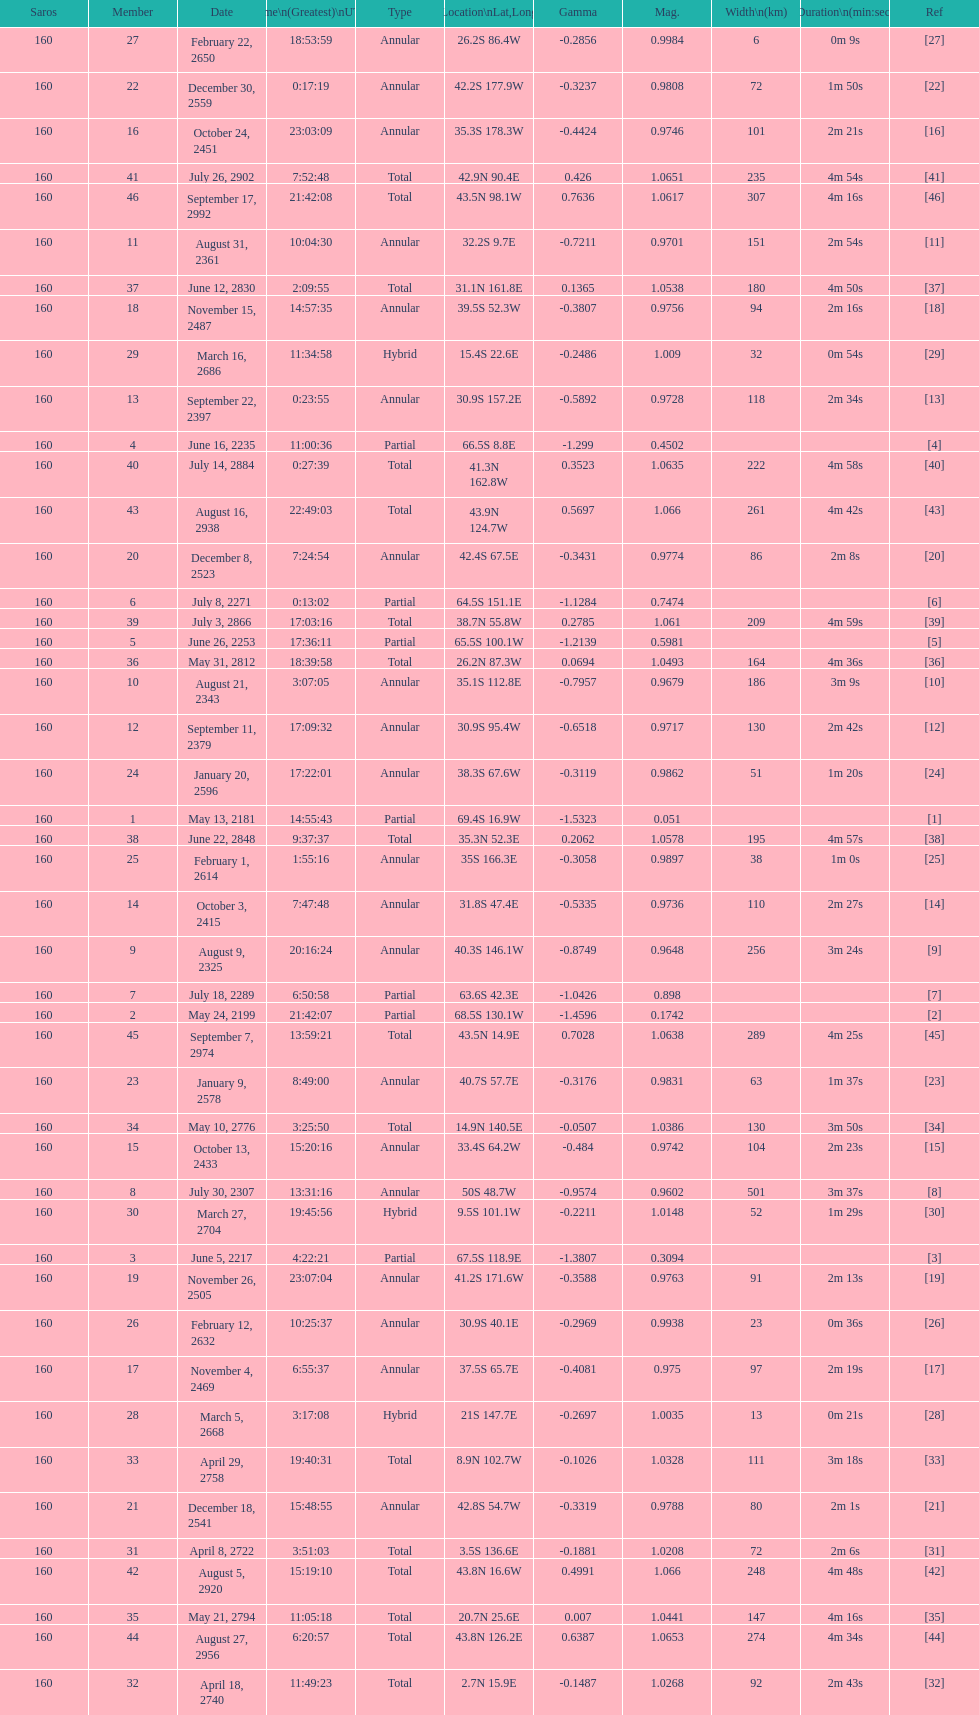How many total events will occur in all? 46. 